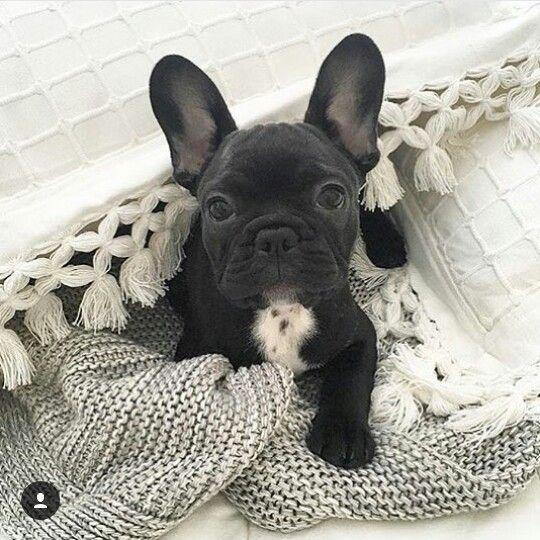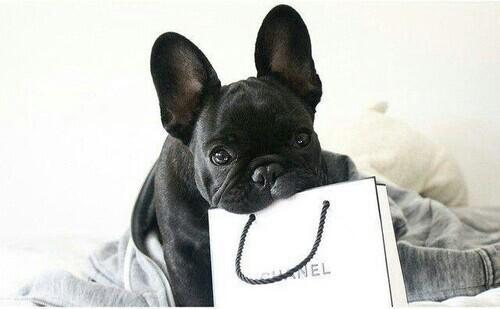The first image is the image on the left, the second image is the image on the right. Analyze the images presented: Is the assertion "One dog has something in his mouth." valid? Answer yes or no. Yes. The first image is the image on the left, the second image is the image on the right. Considering the images on both sides, is "The left image shows a black french bulldog pup posed with another animal figure with upright ears." valid? Answer yes or no. No. 